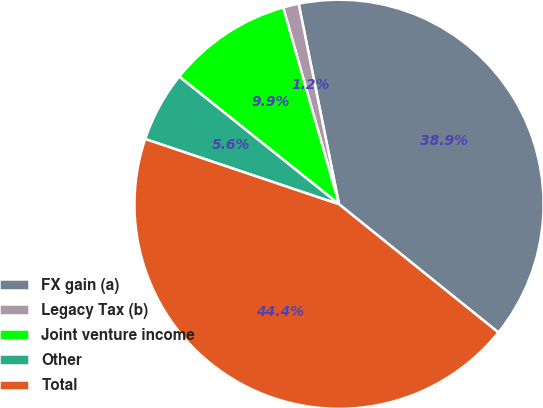Convert chart. <chart><loc_0><loc_0><loc_500><loc_500><pie_chart><fcel>FX gain (a)<fcel>Legacy Tax (b)<fcel>Joint venture income<fcel>Other<fcel>Total<nl><fcel>38.94%<fcel>1.24%<fcel>9.87%<fcel>5.56%<fcel>44.38%<nl></chart> 